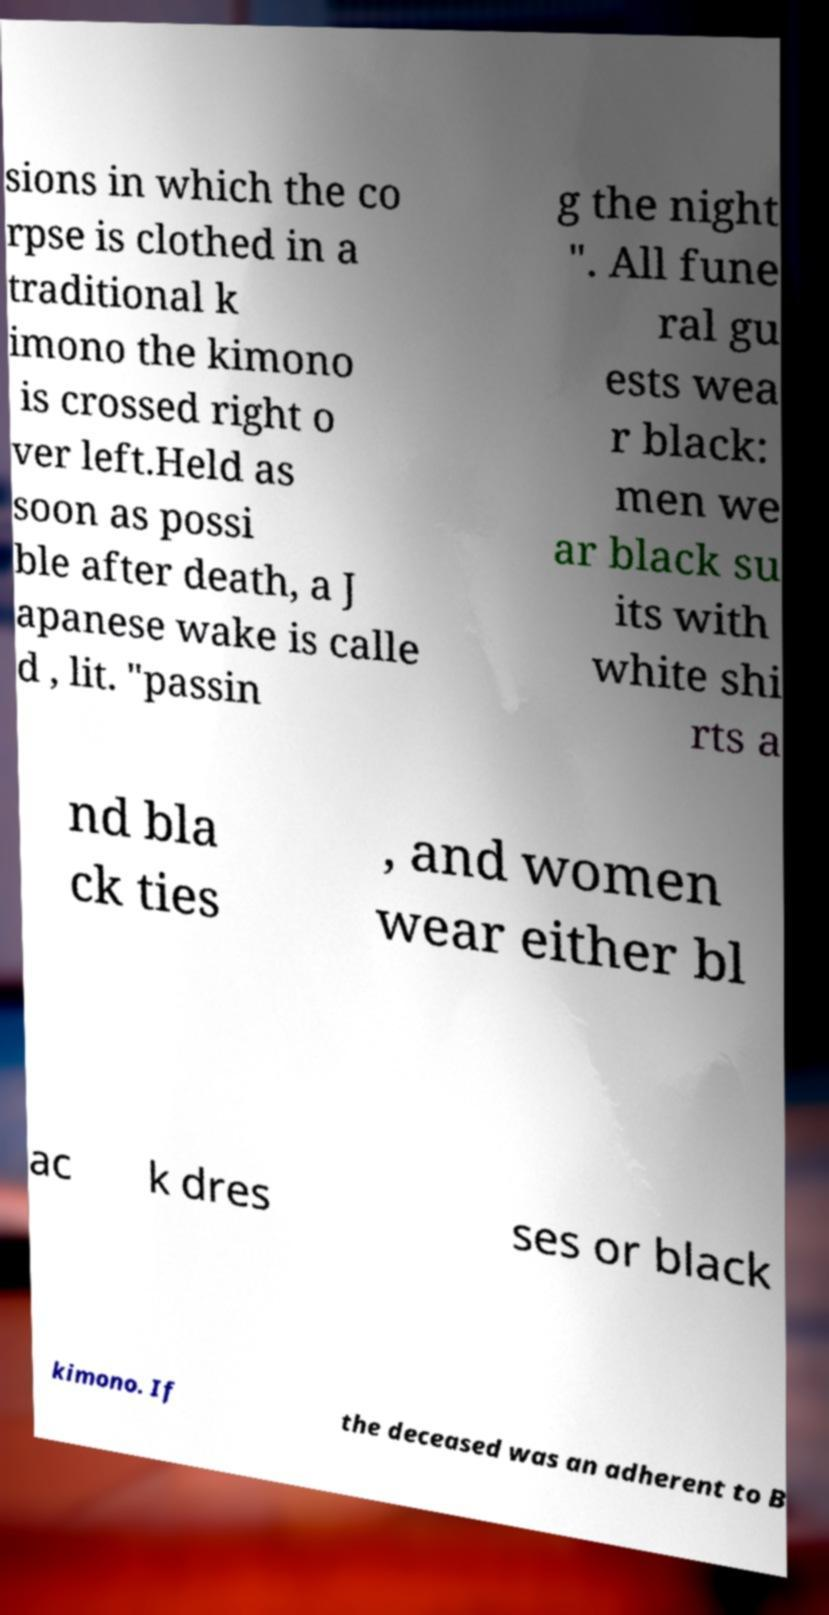I need the written content from this picture converted into text. Can you do that? sions in which the co rpse is clothed in a traditional k imono the kimono is crossed right o ver left.Held as soon as possi ble after death, a J apanese wake is calle d , lit. "passin g the night ". All fune ral gu ests wea r black: men we ar black su its with white shi rts a nd bla ck ties , and women wear either bl ac k dres ses or black kimono. If the deceased was an adherent to B 